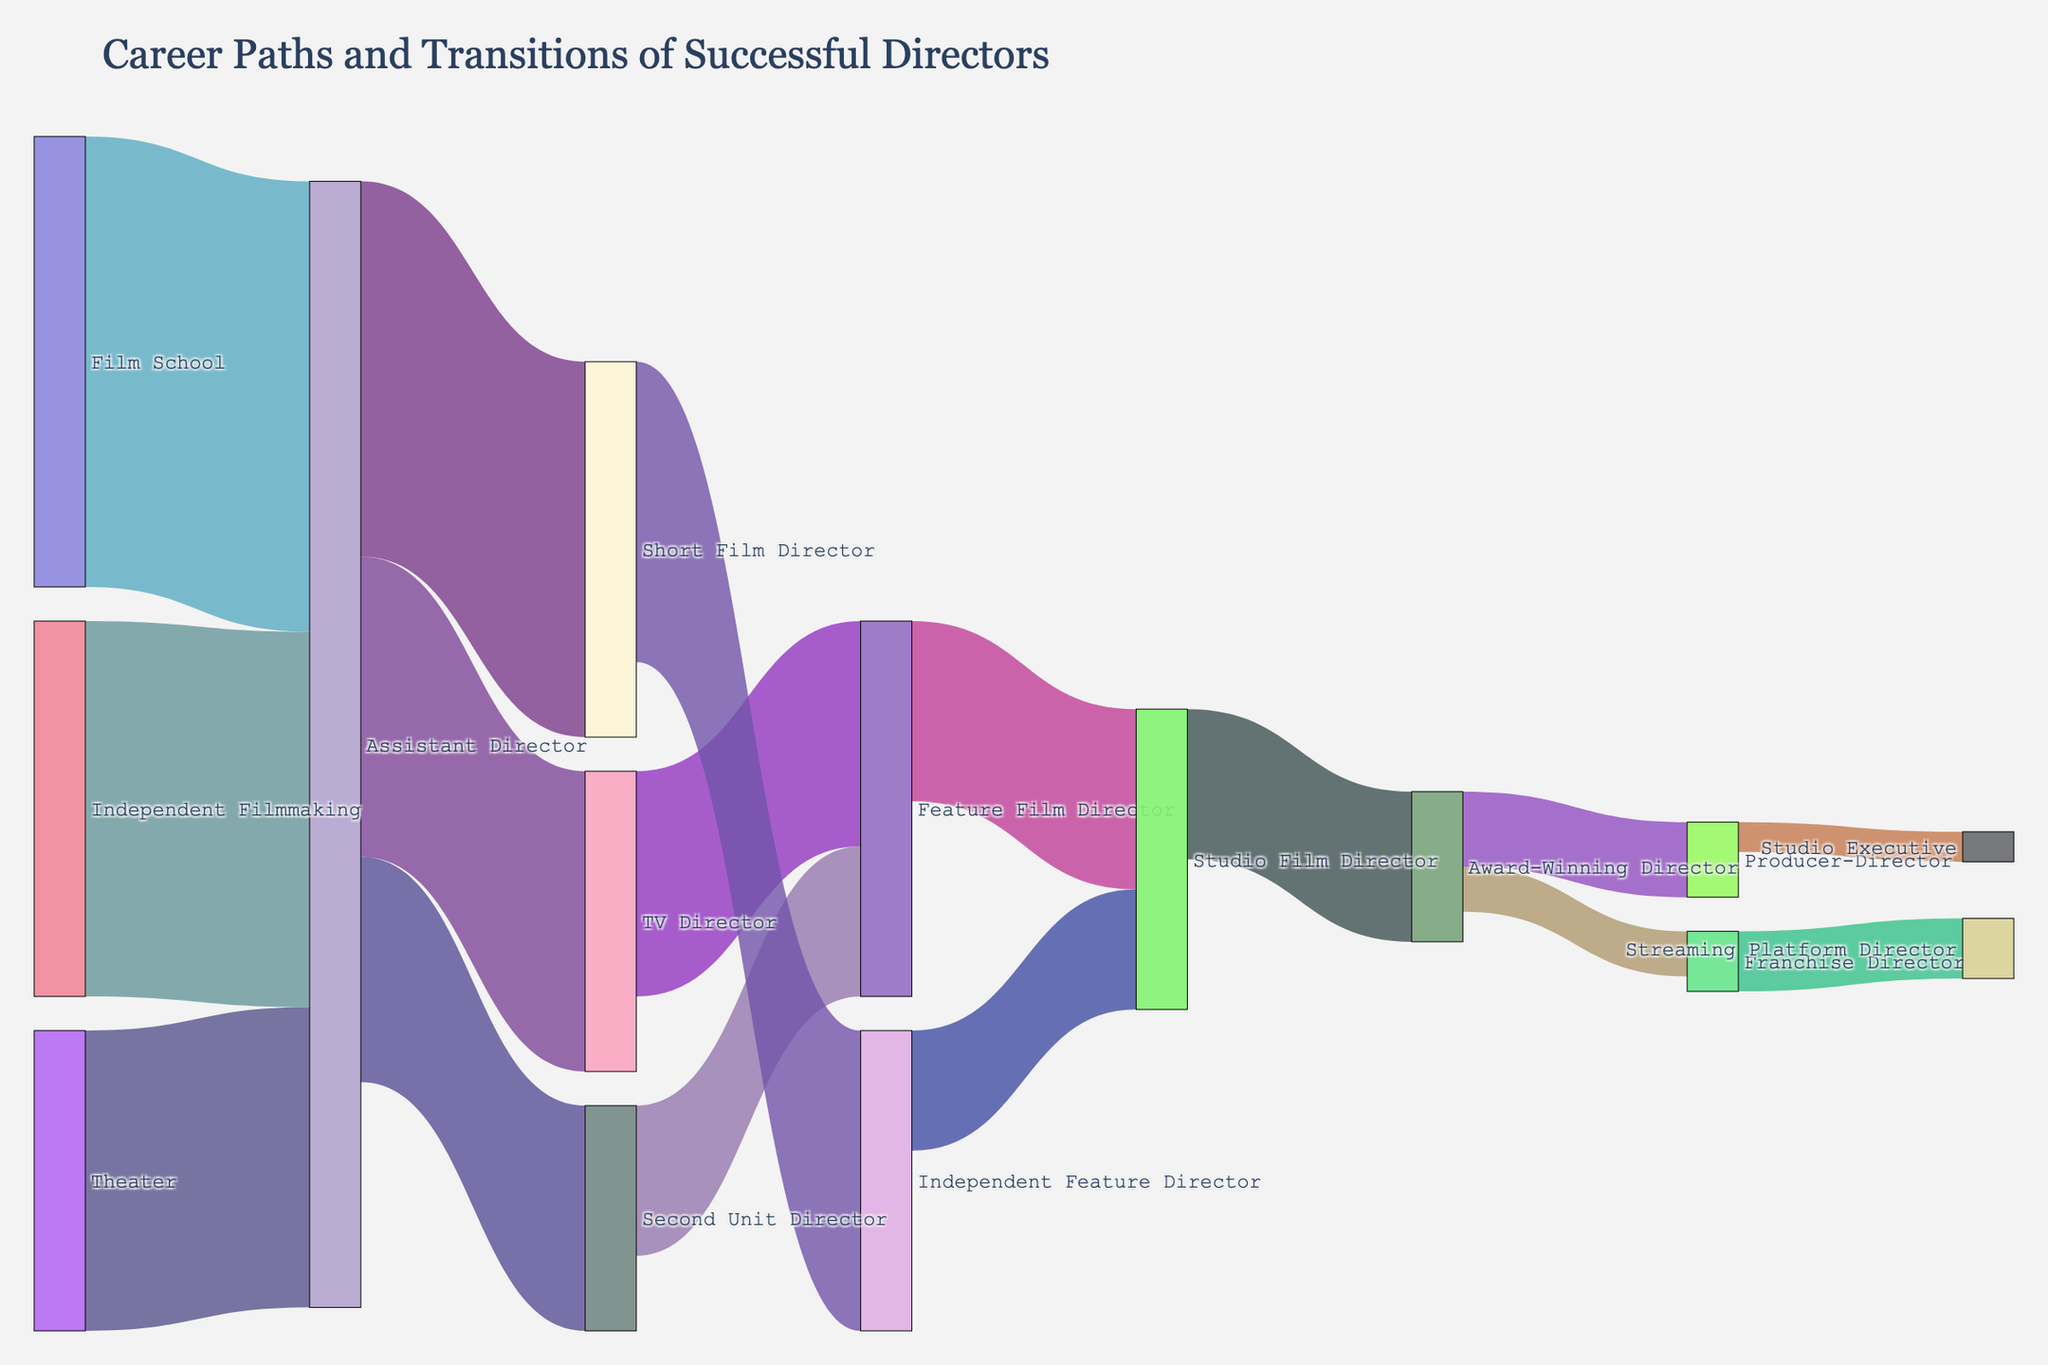What is the title of the Sankey Diagram? The title of the Sankey Diagram is displayed at the top of the figure. It reads "Career Paths and Transitions of Successful Directors."
Answer: Career Paths and Transitions of Successful Directors What career path segment has the highest value in terms of director transitions? By examining the figure, the link with the highest value represents the transition from "Film School" to "Assistant Director," with a value of 30.
Answer: Film School to Assistant Director How many directors transitioned from "Assistant Director" to a directorial role (Second Unit Director, TV Director, or Short Film Director)? To find this, you add up the values for directors transitioning from "Assistant Director" to the directorial roles. This includes 15 (to Second Unit Director), 20 (to TV Director), and 25 (to Short Film Director): 15 + 20 + 25 = 60.
Answer: 60 What are two possible roles a director can progress to after becoming an "Award-Winning Director"? From the figure, two visible target roles for an "Award-Winning Director" are "Producer-Director" and "Franchise Director."
Answer: Producer-Director and Franchise Director Which path has a higher transition value: from "TV Director" to "Feature Film Director" or from "Short Film Director" to "Independent Feature Director"? By comparing the two segments, the transition value from "TV Director" to "Feature Film Director" is 15, while the value from "Short Film Director" to "Independent Feature Director" is 20. Hence, the latter is higher.
Answer: Short Film Director to Independent Feature Director What is the value of transitions from "Studio Film Director" to "Award-Winning Director"? Look at the figure to find the specific link from "Studio Film Director" to "Award-Winning Director," which has a transition value of 10.
Answer: 10 Which career transition has the lower value: from "Producer-Director" to "Studio Executive" or from "Franchise Director" to "Streaming Platform Director"? Comparing the two segments, the value for "Producer-Director" to "Studio Executive" is 2, and for "Franchise Director" to "Streaming Platform Director" is 4. Thus, the former is lower.
Answer: Producer-Director to Studio Executive Can you find a career path that includes three transitions and ends with "Studio Executive"? Trace the longest visual path that ends at "Studio Executive." One such path is "Film School" to "Assistant Director" (30) to "Award-Winning Director" (10) to "Producer-Director" (5) to "Studio Executive" (2). Breaking this down, a possible interpretation would be: 
1. "Assistant Director" to "Award-Winning Director"
2. "Award-Winning Director" to "Producer-Director"
3. "Producer-Director" to "Studio Executive"
Answer: Film School to Assistant Director to Award-Winning Director to Producer-Director to Studio Executive What is the total number of successful director transitions into "Feature Film Director"? Sum the transitions into "Feature Film Director." This includes 10 (from Second Unit Director) and 15 (from TV Director): 10 + 15 = 25.
Answer: 25 